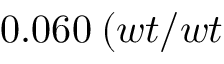Convert formula to latex. <formula><loc_0><loc_0><loc_500><loc_500>0 . 0 6 0 \, ( w t / w t \</formula> 